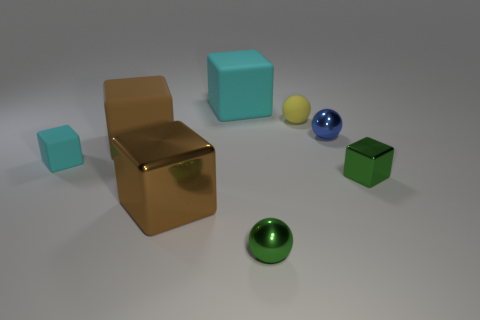Subtract all brown rubber blocks. How many blocks are left? 4 Subtract all green blocks. How many blocks are left? 4 Subtract all green spheres. Subtract all brown cylinders. How many spheres are left? 2 Add 2 small cyan blocks. How many objects exist? 10 Subtract all balls. How many objects are left? 5 Add 1 small metal spheres. How many small metal spheres exist? 3 Subtract 0 purple cylinders. How many objects are left? 8 Subtract all brown shiny things. Subtract all yellow rubber things. How many objects are left? 6 Add 2 small blue shiny balls. How many small blue shiny balls are left? 3 